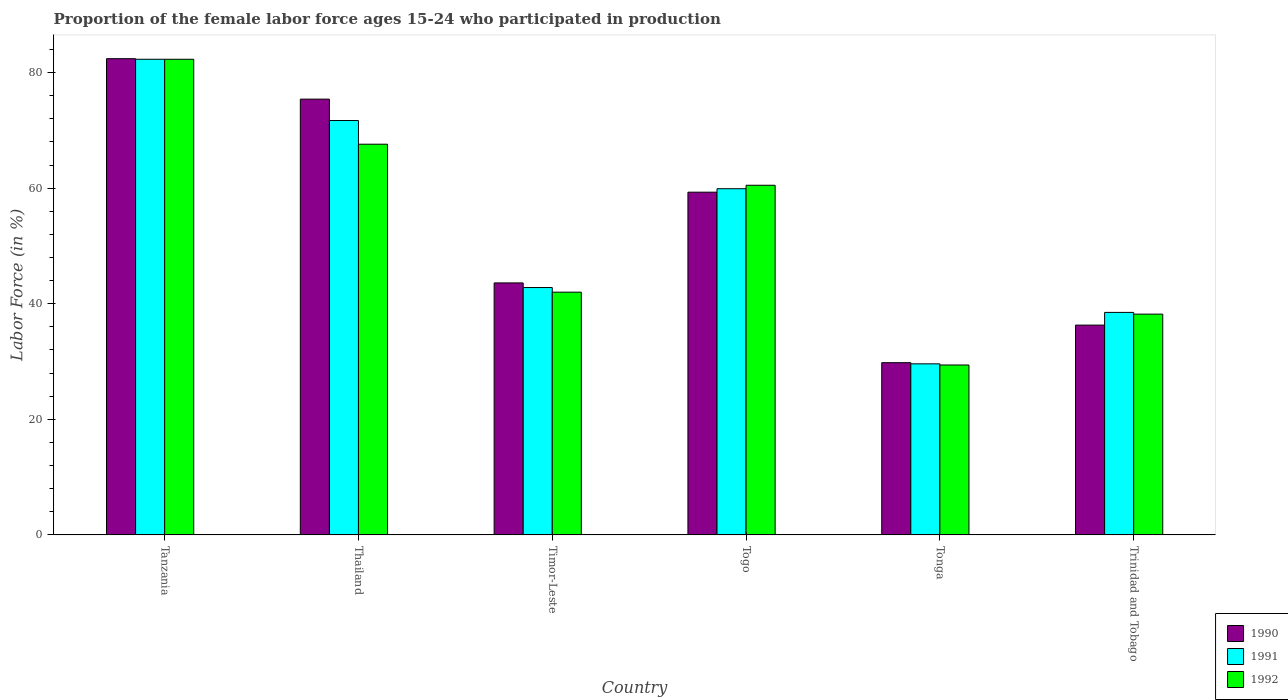How many different coloured bars are there?
Offer a terse response. 3. How many groups of bars are there?
Your response must be concise. 6. How many bars are there on the 1st tick from the left?
Provide a succinct answer. 3. How many bars are there on the 4th tick from the right?
Give a very brief answer. 3. What is the label of the 3rd group of bars from the left?
Offer a terse response. Timor-Leste. What is the proportion of the female labor force who participated in production in 1991 in Thailand?
Offer a terse response. 71.7. Across all countries, what is the maximum proportion of the female labor force who participated in production in 1992?
Offer a very short reply. 82.3. Across all countries, what is the minimum proportion of the female labor force who participated in production in 1991?
Provide a succinct answer. 29.6. In which country was the proportion of the female labor force who participated in production in 1991 maximum?
Provide a succinct answer. Tanzania. In which country was the proportion of the female labor force who participated in production in 1990 minimum?
Keep it short and to the point. Tonga. What is the total proportion of the female labor force who participated in production in 1990 in the graph?
Your answer should be very brief. 326.8. What is the difference between the proportion of the female labor force who participated in production in 1991 in Tonga and that in Trinidad and Tobago?
Offer a terse response. -8.9. What is the difference between the proportion of the female labor force who participated in production in 1992 in Thailand and the proportion of the female labor force who participated in production in 1991 in Tanzania?
Give a very brief answer. -14.7. What is the average proportion of the female labor force who participated in production in 1991 per country?
Your response must be concise. 54.13. What is the difference between the proportion of the female labor force who participated in production of/in 1992 and proportion of the female labor force who participated in production of/in 1991 in Tanzania?
Offer a terse response. 0. In how many countries, is the proportion of the female labor force who participated in production in 1992 greater than 24 %?
Keep it short and to the point. 6. What is the ratio of the proportion of the female labor force who participated in production in 1992 in Timor-Leste to that in Togo?
Provide a short and direct response. 0.69. Is the difference between the proportion of the female labor force who participated in production in 1992 in Timor-Leste and Tonga greater than the difference between the proportion of the female labor force who participated in production in 1991 in Timor-Leste and Tonga?
Your answer should be very brief. No. What is the difference between the highest and the second highest proportion of the female labor force who participated in production in 1992?
Make the answer very short. 14.7. What is the difference between the highest and the lowest proportion of the female labor force who participated in production in 1992?
Make the answer very short. 52.9. In how many countries, is the proportion of the female labor force who participated in production in 1991 greater than the average proportion of the female labor force who participated in production in 1991 taken over all countries?
Offer a terse response. 3. What does the 2nd bar from the left in Timor-Leste represents?
Ensure brevity in your answer.  1991. What does the 2nd bar from the right in Tanzania represents?
Provide a succinct answer. 1991. Are all the bars in the graph horizontal?
Provide a short and direct response. No. How many countries are there in the graph?
Offer a very short reply. 6. What is the difference between two consecutive major ticks on the Y-axis?
Your answer should be compact. 20. Does the graph contain any zero values?
Offer a terse response. No. Does the graph contain grids?
Your answer should be very brief. No. How are the legend labels stacked?
Provide a succinct answer. Vertical. What is the title of the graph?
Your response must be concise. Proportion of the female labor force ages 15-24 who participated in production. Does "2003" appear as one of the legend labels in the graph?
Your response must be concise. No. What is the label or title of the X-axis?
Your answer should be compact. Country. What is the Labor Force (in %) in 1990 in Tanzania?
Provide a succinct answer. 82.4. What is the Labor Force (in %) in 1991 in Tanzania?
Make the answer very short. 82.3. What is the Labor Force (in %) of 1992 in Tanzania?
Provide a succinct answer. 82.3. What is the Labor Force (in %) of 1990 in Thailand?
Provide a succinct answer. 75.4. What is the Labor Force (in %) in 1991 in Thailand?
Your response must be concise. 71.7. What is the Labor Force (in %) of 1992 in Thailand?
Provide a short and direct response. 67.6. What is the Labor Force (in %) of 1990 in Timor-Leste?
Make the answer very short. 43.6. What is the Labor Force (in %) in 1991 in Timor-Leste?
Keep it short and to the point. 42.8. What is the Labor Force (in %) in 1990 in Togo?
Offer a terse response. 59.3. What is the Labor Force (in %) of 1991 in Togo?
Offer a terse response. 59.9. What is the Labor Force (in %) of 1992 in Togo?
Make the answer very short. 60.5. What is the Labor Force (in %) in 1990 in Tonga?
Offer a terse response. 29.8. What is the Labor Force (in %) of 1991 in Tonga?
Offer a terse response. 29.6. What is the Labor Force (in %) of 1992 in Tonga?
Provide a short and direct response. 29.4. What is the Labor Force (in %) of 1990 in Trinidad and Tobago?
Offer a terse response. 36.3. What is the Labor Force (in %) in 1991 in Trinidad and Tobago?
Your answer should be compact. 38.5. What is the Labor Force (in %) of 1992 in Trinidad and Tobago?
Give a very brief answer. 38.2. Across all countries, what is the maximum Labor Force (in %) in 1990?
Your answer should be compact. 82.4. Across all countries, what is the maximum Labor Force (in %) of 1991?
Your answer should be very brief. 82.3. Across all countries, what is the maximum Labor Force (in %) of 1992?
Your answer should be compact. 82.3. Across all countries, what is the minimum Labor Force (in %) in 1990?
Offer a terse response. 29.8. Across all countries, what is the minimum Labor Force (in %) of 1991?
Your answer should be compact. 29.6. Across all countries, what is the minimum Labor Force (in %) of 1992?
Your response must be concise. 29.4. What is the total Labor Force (in %) in 1990 in the graph?
Keep it short and to the point. 326.8. What is the total Labor Force (in %) in 1991 in the graph?
Your answer should be compact. 324.8. What is the total Labor Force (in %) of 1992 in the graph?
Ensure brevity in your answer.  320. What is the difference between the Labor Force (in %) in 1991 in Tanzania and that in Thailand?
Your answer should be compact. 10.6. What is the difference between the Labor Force (in %) of 1990 in Tanzania and that in Timor-Leste?
Ensure brevity in your answer.  38.8. What is the difference between the Labor Force (in %) of 1991 in Tanzania and that in Timor-Leste?
Your response must be concise. 39.5. What is the difference between the Labor Force (in %) in 1992 in Tanzania and that in Timor-Leste?
Your answer should be compact. 40.3. What is the difference between the Labor Force (in %) in 1990 in Tanzania and that in Togo?
Ensure brevity in your answer.  23.1. What is the difference between the Labor Force (in %) in 1991 in Tanzania and that in Togo?
Provide a short and direct response. 22.4. What is the difference between the Labor Force (in %) in 1992 in Tanzania and that in Togo?
Your response must be concise. 21.8. What is the difference between the Labor Force (in %) of 1990 in Tanzania and that in Tonga?
Offer a very short reply. 52.6. What is the difference between the Labor Force (in %) of 1991 in Tanzania and that in Tonga?
Your answer should be compact. 52.7. What is the difference between the Labor Force (in %) in 1992 in Tanzania and that in Tonga?
Your answer should be compact. 52.9. What is the difference between the Labor Force (in %) in 1990 in Tanzania and that in Trinidad and Tobago?
Offer a terse response. 46.1. What is the difference between the Labor Force (in %) in 1991 in Tanzania and that in Trinidad and Tobago?
Keep it short and to the point. 43.8. What is the difference between the Labor Force (in %) in 1992 in Tanzania and that in Trinidad and Tobago?
Keep it short and to the point. 44.1. What is the difference between the Labor Force (in %) of 1990 in Thailand and that in Timor-Leste?
Make the answer very short. 31.8. What is the difference between the Labor Force (in %) of 1991 in Thailand and that in Timor-Leste?
Your response must be concise. 28.9. What is the difference between the Labor Force (in %) of 1992 in Thailand and that in Timor-Leste?
Your response must be concise. 25.6. What is the difference between the Labor Force (in %) in 1990 in Thailand and that in Tonga?
Offer a terse response. 45.6. What is the difference between the Labor Force (in %) of 1991 in Thailand and that in Tonga?
Provide a succinct answer. 42.1. What is the difference between the Labor Force (in %) in 1992 in Thailand and that in Tonga?
Ensure brevity in your answer.  38.2. What is the difference between the Labor Force (in %) in 1990 in Thailand and that in Trinidad and Tobago?
Ensure brevity in your answer.  39.1. What is the difference between the Labor Force (in %) of 1991 in Thailand and that in Trinidad and Tobago?
Provide a succinct answer. 33.2. What is the difference between the Labor Force (in %) of 1992 in Thailand and that in Trinidad and Tobago?
Give a very brief answer. 29.4. What is the difference between the Labor Force (in %) of 1990 in Timor-Leste and that in Togo?
Your answer should be very brief. -15.7. What is the difference between the Labor Force (in %) in 1991 in Timor-Leste and that in Togo?
Offer a terse response. -17.1. What is the difference between the Labor Force (in %) in 1992 in Timor-Leste and that in Togo?
Provide a succinct answer. -18.5. What is the difference between the Labor Force (in %) in 1990 in Timor-Leste and that in Tonga?
Offer a terse response. 13.8. What is the difference between the Labor Force (in %) in 1991 in Timor-Leste and that in Tonga?
Offer a terse response. 13.2. What is the difference between the Labor Force (in %) of 1991 in Timor-Leste and that in Trinidad and Tobago?
Provide a short and direct response. 4.3. What is the difference between the Labor Force (in %) of 1992 in Timor-Leste and that in Trinidad and Tobago?
Offer a terse response. 3.8. What is the difference between the Labor Force (in %) in 1990 in Togo and that in Tonga?
Offer a terse response. 29.5. What is the difference between the Labor Force (in %) in 1991 in Togo and that in Tonga?
Your response must be concise. 30.3. What is the difference between the Labor Force (in %) in 1992 in Togo and that in Tonga?
Give a very brief answer. 31.1. What is the difference between the Labor Force (in %) of 1990 in Togo and that in Trinidad and Tobago?
Offer a very short reply. 23. What is the difference between the Labor Force (in %) in 1991 in Togo and that in Trinidad and Tobago?
Your answer should be compact. 21.4. What is the difference between the Labor Force (in %) of 1992 in Togo and that in Trinidad and Tobago?
Your answer should be compact. 22.3. What is the difference between the Labor Force (in %) of 1990 in Tonga and that in Trinidad and Tobago?
Your answer should be compact. -6.5. What is the difference between the Labor Force (in %) of 1991 in Tonga and that in Trinidad and Tobago?
Your answer should be very brief. -8.9. What is the difference between the Labor Force (in %) of 1992 in Tonga and that in Trinidad and Tobago?
Provide a short and direct response. -8.8. What is the difference between the Labor Force (in %) of 1990 in Tanzania and the Labor Force (in %) of 1991 in Thailand?
Provide a succinct answer. 10.7. What is the difference between the Labor Force (in %) of 1990 in Tanzania and the Labor Force (in %) of 1992 in Thailand?
Your answer should be compact. 14.8. What is the difference between the Labor Force (in %) of 1991 in Tanzania and the Labor Force (in %) of 1992 in Thailand?
Provide a succinct answer. 14.7. What is the difference between the Labor Force (in %) in 1990 in Tanzania and the Labor Force (in %) in 1991 in Timor-Leste?
Offer a terse response. 39.6. What is the difference between the Labor Force (in %) in 1990 in Tanzania and the Labor Force (in %) in 1992 in Timor-Leste?
Offer a terse response. 40.4. What is the difference between the Labor Force (in %) of 1991 in Tanzania and the Labor Force (in %) of 1992 in Timor-Leste?
Your answer should be very brief. 40.3. What is the difference between the Labor Force (in %) in 1990 in Tanzania and the Labor Force (in %) in 1992 in Togo?
Keep it short and to the point. 21.9. What is the difference between the Labor Force (in %) of 1991 in Tanzania and the Labor Force (in %) of 1992 in Togo?
Offer a terse response. 21.8. What is the difference between the Labor Force (in %) of 1990 in Tanzania and the Labor Force (in %) of 1991 in Tonga?
Ensure brevity in your answer.  52.8. What is the difference between the Labor Force (in %) of 1990 in Tanzania and the Labor Force (in %) of 1992 in Tonga?
Offer a terse response. 53. What is the difference between the Labor Force (in %) of 1991 in Tanzania and the Labor Force (in %) of 1992 in Tonga?
Keep it short and to the point. 52.9. What is the difference between the Labor Force (in %) in 1990 in Tanzania and the Labor Force (in %) in 1991 in Trinidad and Tobago?
Keep it short and to the point. 43.9. What is the difference between the Labor Force (in %) of 1990 in Tanzania and the Labor Force (in %) of 1992 in Trinidad and Tobago?
Your answer should be very brief. 44.2. What is the difference between the Labor Force (in %) in 1991 in Tanzania and the Labor Force (in %) in 1992 in Trinidad and Tobago?
Provide a succinct answer. 44.1. What is the difference between the Labor Force (in %) in 1990 in Thailand and the Labor Force (in %) in 1991 in Timor-Leste?
Provide a short and direct response. 32.6. What is the difference between the Labor Force (in %) of 1990 in Thailand and the Labor Force (in %) of 1992 in Timor-Leste?
Keep it short and to the point. 33.4. What is the difference between the Labor Force (in %) in 1991 in Thailand and the Labor Force (in %) in 1992 in Timor-Leste?
Offer a terse response. 29.7. What is the difference between the Labor Force (in %) of 1990 in Thailand and the Labor Force (in %) of 1991 in Togo?
Make the answer very short. 15.5. What is the difference between the Labor Force (in %) of 1990 in Thailand and the Labor Force (in %) of 1992 in Togo?
Give a very brief answer. 14.9. What is the difference between the Labor Force (in %) in 1991 in Thailand and the Labor Force (in %) in 1992 in Togo?
Ensure brevity in your answer.  11.2. What is the difference between the Labor Force (in %) in 1990 in Thailand and the Labor Force (in %) in 1991 in Tonga?
Offer a terse response. 45.8. What is the difference between the Labor Force (in %) in 1991 in Thailand and the Labor Force (in %) in 1992 in Tonga?
Your answer should be very brief. 42.3. What is the difference between the Labor Force (in %) in 1990 in Thailand and the Labor Force (in %) in 1991 in Trinidad and Tobago?
Keep it short and to the point. 36.9. What is the difference between the Labor Force (in %) in 1990 in Thailand and the Labor Force (in %) in 1992 in Trinidad and Tobago?
Ensure brevity in your answer.  37.2. What is the difference between the Labor Force (in %) of 1991 in Thailand and the Labor Force (in %) of 1992 in Trinidad and Tobago?
Your answer should be compact. 33.5. What is the difference between the Labor Force (in %) in 1990 in Timor-Leste and the Labor Force (in %) in 1991 in Togo?
Provide a succinct answer. -16.3. What is the difference between the Labor Force (in %) of 1990 in Timor-Leste and the Labor Force (in %) of 1992 in Togo?
Give a very brief answer. -16.9. What is the difference between the Labor Force (in %) in 1991 in Timor-Leste and the Labor Force (in %) in 1992 in Togo?
Your answer should be very brief. -17.7. What is the difference between the Labor Force (in %) in 1990 in Timor-Leste and the Labor Force (in %) in 1991 in Tonga?
Your answer should be very brief. 14. What is the difference between the Labor Force (in %) of 1990 in Timor-Leste and the Labor Force (in %) of 1992 in Tonga?
Your answer should be compact. 14.2. What is the difference between the Labor Force (in %) of 1990 in Timor-Leste and the Labor Force (in %) of 1992 in Trinidad and Tobago?
Offer a very short reply. 5.4. What is the difference between the Labor Force (in %) in 1990 in Togo and the Labor Force (in %) in 1991 in Tonga?
Ensure brevity in your answer.  29.7. What is the difference between the Labor Force (in %) of 1990 in Togo and the Labor Force (in %) of 1992 in Tonga?
Ensure brevity in your answer.  29.9. What is the difference between the Labor Force (in %) of 1991 in Togo and the Labor Force (in %) of 1992 in Tonga?
Ensure brevity in your answer.  30.5. What is the difference between the Labor Force (in %) of 1990 in Togo and the Labor Force (in %) of 1991 in Trinidad and Tobago?
Provide a succinct answer. 20.8. What is the difference between the Labor Force (in %) of 1990 in Togo and the Labor Force (in %) of 1992 in Trinidad and Tobago?
Give a very brief answer. 21.1. What is the difference between the Labor Force (in %) in 1991 in Togo and the Labor Force (in %) in 1992 in Trinidad and Tobago?
Your answer should be compact. 21.7. What is the difference between the Labor Force (in %) of 1990 in Tonga and the Labor Force (in %) of 1992 in Trinidad and Tobago?
Offer a terse response. -8.4. What is the difference between the Labor Force (in %) of 1991 in Tonga and the Labor Force (in %) of 1992 in Trinidad and Tobago?
Offer a terse response. -8.6. What is the average Labor Force (in %) in 1990 per country?
Offer a terse response. 54.47. What is the average Labor Force (in %) in 1991 per country?
Provide a succinct answer. 54.13. What is the average Labor Force (in %) of 1992 per country?
Your answer should be very brief. 53.33. What is the difference between the Labor Force (in %) in 1990 and Labor Force (in %) in 1992 in Tanzania?
Provide a short and direct response. 0.1. What is the difference between the Labor Force (in %) in 1991 and Labor Force (in %) in 1992 in Tanzania?
Offer a terse response. 0. What is the difference between the Labor Force (in %) in 1990 and Labor Force (in %) in 1991 in Thailand?
Make the answer very short. 3.7. What is the difference between the Labor Force (in %) of 1991 and Labor Force (in %) of 1992 in Thailand?
Keep it short and to the point. 4.1. What is the difference between the Labor Force (in %) in 1990 and Labor Force (in %) in 1991 in Timor-Leste?
Ensure brevity in your answer.  0.8. What is the difference between the Labor Force (in %) in 1990 and Labor Force (in %) in 1992 in Timor-Leste?
Give a very brief answer. 1.6. What is the difference between the Labor Force (in %) of 1991 and Labor Force (in %) of 1992 in Timor-Leste?
Provide a short and direct response. 0.8. What is the difference between the Labor Force (in %) in 1990 and Labor Force (in %) in 1991 in Togo?
Your answer should be very brief. -0.6. What is the difference between the Labor Force (in %) of 1990 and Labor Force (in %) of 1992 in Togo?
Provide a succinct answer. -1.2. What is the difference between the Labor Force (in %) of 1990 and Labor Force (in %) of 1991 in Tonga?
Keep it short and to the point. 0.2. What is the ratio of the Labor Force (in %) in 1990 in Tanzania to that in Thailand?
Make the answer very short. 1.09. What is the ratio of the Labor Force (in %) of 1991 in Tanzania to that in Thailand?
Your answer should be very brief. 1.15. What is the ratio of the Labor Force (in %) in 1992 in Tanzania to that in Thailand?
Provide a succinct answer. 1.22. What is the ratio of the Labor Force (in %) of 1990 in Tanzania to that in Timor-Leste?
Keep it short and to the point. 1.89. What is the ratio of the Labor Force (in %) in 1991 in Tanzania to that in Timor-Leste?
Give a very brief answer. 1.92. What is the ratio of the Labor Force (in %) of 1992 in Tanzania to that in Timor-Leste?
Your answer should be very brief. 1.96. What is the ratio of the Labor Force (in %) in 1990 in Tanzania to that in Togo?
Your answer should be compact. 1.39. What is the ratio of the Labor Force (in %) of 1991 in Tanzania to that in Togo?
Keep it short and to the point. 1.37. What is the ratio of the Labor Force (in %) of 1992 in Tanzania to that in Togo?
Give a very brief answer. 1.36. What is the ratio of the Labor Force (in %) of 1990 in Tanzania to that in Tonga?
Make the answer very short. 2.77. What is the ratio of the Labor Force (in %) in 1991 in Tanzania to that in Tonga?
Offer a very short reply. 2.78. What is the ratio of the Labor Force (in %) of 1992 in Tanzania to that in Tonga?
Give a very brief answer. 2.8. What is the ratio of the Labor Force (in %) in 1990 in Tanzania to that in Trinidad and Tobago?
Provide a short and direct response. 2.27. What is the ratio of the Labor Force (in %) of 1991 in Tanzania to that in Trinidad and Tobago?
Make the answer very short. 2.14. What is the ratio of the Labor Force (in %) in 1992 in Tanzania to that in Trinidad and Tobago?
Your response must be concise. 2.15. What is the ratio of the Labor Force (in %) in 1990 in Thailand to that in Timor-Leste?
Give a very brief answer. 1.73. What is the ratio of the Labor Force (in %) in 1991 in Thailand to that in Timor-Leste?
Provide a short and direct response. 1.68. What is the ratio of the Labor Force (in %) of 1992 in Thailand to that in Timor-Leste?
Your response must be concise. 1.61. What is the ratio of the Labor Force (in %) in 1990 in Thailand to that in Togo?
Give a very brief answer. 1.27. What is the ratio of the Labor Force (in %) of 1991 in Thailand to that in Togo?
Your answer should be very brief. 1.2. What is the ratio of the Labor Force (in %) of 1992 in Thailand to that in Togo?
Your answer should be very brief. 1.12. What is the ratio of the Labor Force (in %) of 1990 in Thailand to that in Tonga?
Your answer should be very brief. 2.53. What is the ratio of the Labor Force (in %) in 1991 in Thailand to that in Tonga?
Keep it short and to the point. 2.42. What is the ratio of the Labor Force (in %) in 1992 in Thailand to that in Tonga?
Provide a short and direct response. 2.3. What is the ratio of the Labor Force (in %) in 1990 in Thailand to that in Trinidad and Tobago?
Provide a succinct answer. 2.08. What is the ratio of the Labor Force (in %) of 1991 in Thailand to that in Trinidad and Tobago?
Keep it short and to the point. 1.86. What is the ratio of the Labor Force (in %) in 1992 in Thailand to that in Trinidad and Tobago?
Offer a very short reply. 1.77. What is the ratio of the Labor Force (in %) in 1990 in Timor-Leste to that in Togo?
Provide a short and direct response. 0.74. What is the ratio of the Labor Force (in %) of 1991 in Timor-Leste to that in Togo?
Make the answer very short. 0.71. What is the ratio of the Labor Force (in %) of 1992 in Timor-Leste to that in Togo?
Your answer should be compact. 0.69. What is the ratio of the Labor Force (in %) of 1990 in Timor-Leste to that in Tonga?
Offer a terse response. 1.46. What is the ratio of the Labor Force (in %) of 1991 in Timor-Leste to that in Tonga?
Provide a short and direct response. 1.45. What is the ratio of the Labor Force (in %) of 1992 in Timor-Leste to that in Tonga?
Provide a short and direct response. 1.43. What is the ratio of the Labor Force (in %) of 1990 in Timor-Leste to that in Trinidad and Tobago?
Ensure brevity in your answer.  1.2. What is the ratio of the Labor Force (in %) of 1991 in Timor-Leste to that in Trinidad and Tobago?
Give a very brief answer. 1.11. What is the ratio of the Labor Force (in %) of 1992 in Timor-Leste to that in Trinidad and Tobago?
Keep it short and to the point. 1.1. What is the ratio of the Labor Force (in %) in 1990 in Togo to that in Tonga?
Make the answer very short. 1.99. What is the ratio of the Labor Force (in %) in 1991 in Togo to that in Tonga?
Give a very brief answer. 2.02. What is the ratio of the Labor Force (in %) of 1992 in Togo to that in Tonga?
Make the answer very short. 2.06. What is the ratio of the Labor Force (in %) in 1990 in Togo to that in Trinidad and Tobago?
Your response must be concise. 1.63. What is the ratio of the Labor Force (in %) in 1991 in Togo to that in Trinidad and Tobago?
Give a very brief answer. 1.56. What is the ratio of the Labor Force (in %) of 1992 in Togo to that in Trinidad and Tobago?
Offer a very short reply. 1.58. What is the ratio of the Labor Force (in %) of 1990 in Tonga to that in Trinidad and Tobago?
Your answer should be compact. 0.82. What is the ratio of the Labor Force (in %) of 1991 in Tonga to that in Trinidad and Tobago?
Provide a short and direct response. 0.77. What is the ratio of the Labor Force (in %) in 1992 in Tonga to that in Trinidad and Tobago?
Provide a succinct answer. 0.77. What is the difference between the highest and the second highest Labor Force (in %) in 1991?
Make the answer very short. 10.6. What is the difference between the highest and the lowest Labor Force (in %) of 1990?
Keep it short and to the point. 52.6. What is the difference between the highest and the lowest Labor Force (in %) in 1991?
Your response must be concise. 52.7. What is the difference between the highest and the lowest Labor Force (in %) of 1992?
Your response must be concise. 52.9. 